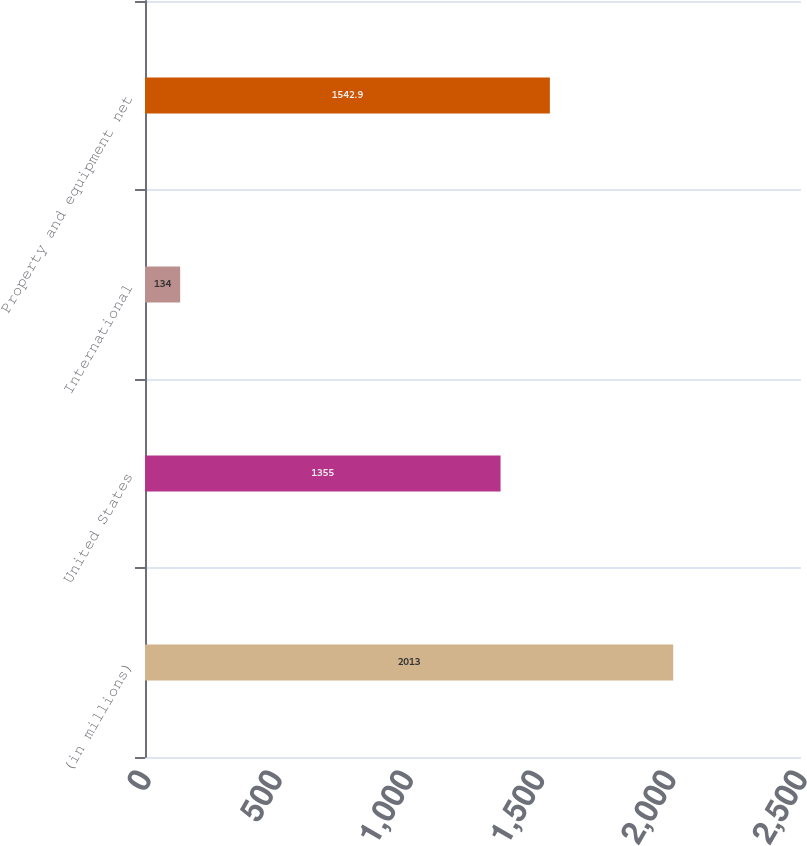Convert chart. <chart><loc_0><loc_0><loc_500><loc_500><bar_chart><fcel>(in millions)<fcel>United States<fcel>International<fcel>Property and equipment net<nl><fcel>2013<fcel>1355<fcel>134<fcel>1542.9<nl></chart> 